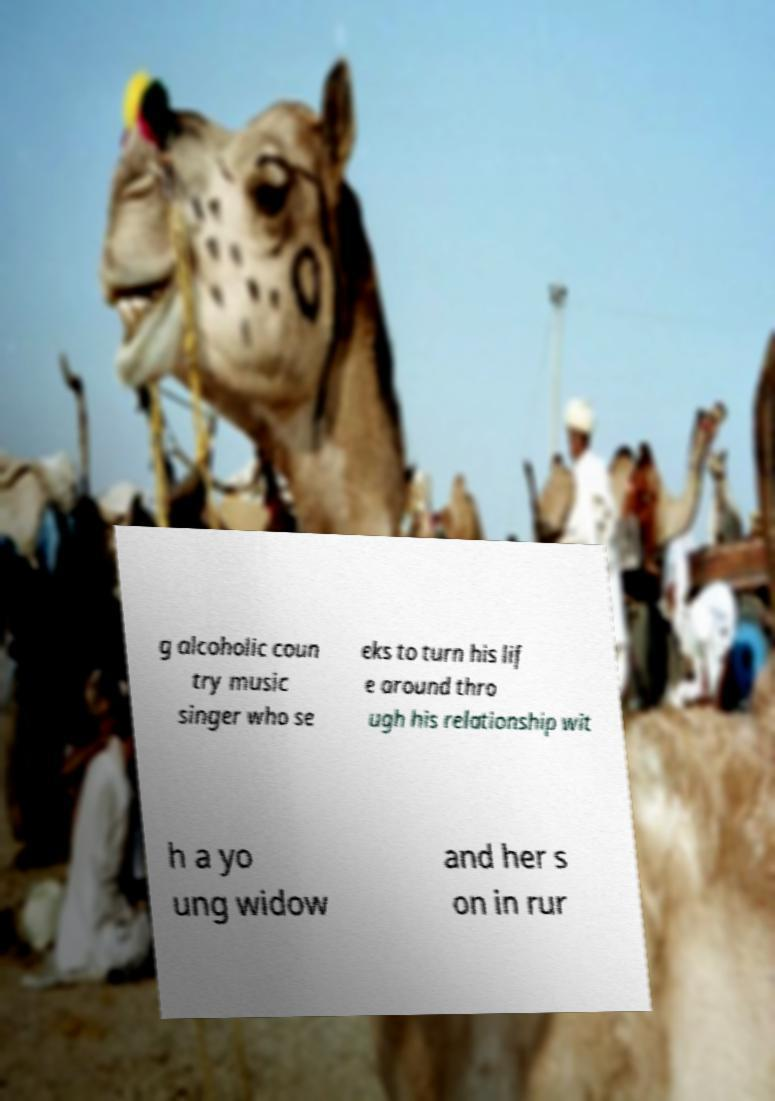Can you read and provide the text displayed in the image?This photo seems to have some interesting text. Can you extract and type it out for me? g alcoholic coun try music singer who se eks to turn his lif e around thro ugh his relationship wit h a yo ung widow and her s on in rur 